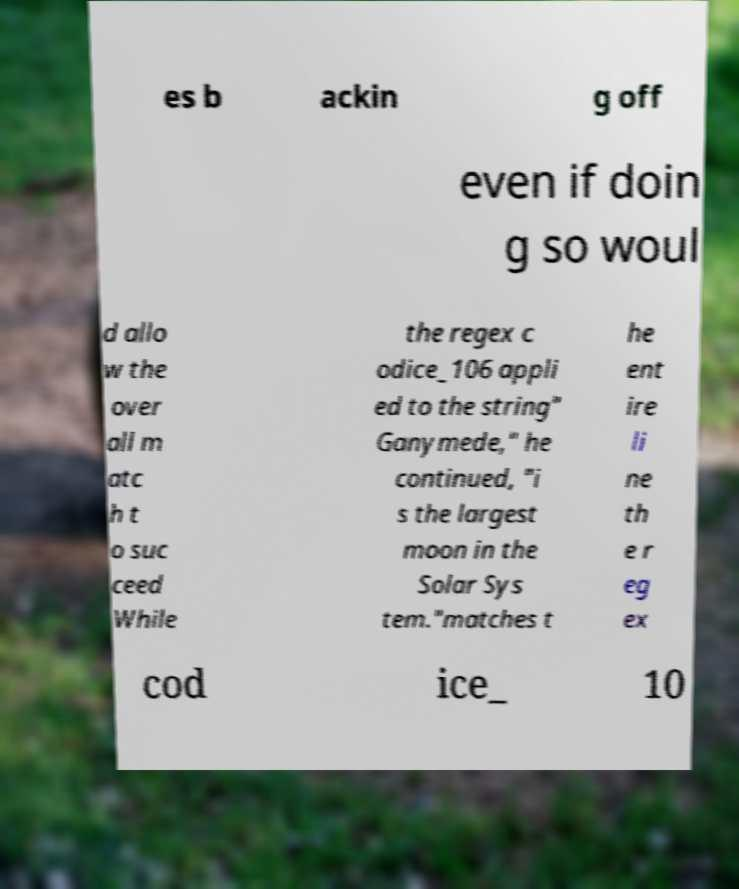What messages or text are displayed in this image? I need them in a readable, typed format. es b ackin g off even if doin g so woul d allo w the over all m atc h t o suc ceed While the regex c odice_106 appli ed to the string" Ganymede," he continued, "i s the largest moon in the Solar Sys tem."matches t he ent ire li ne th e r eg ex cod ice_ 10 